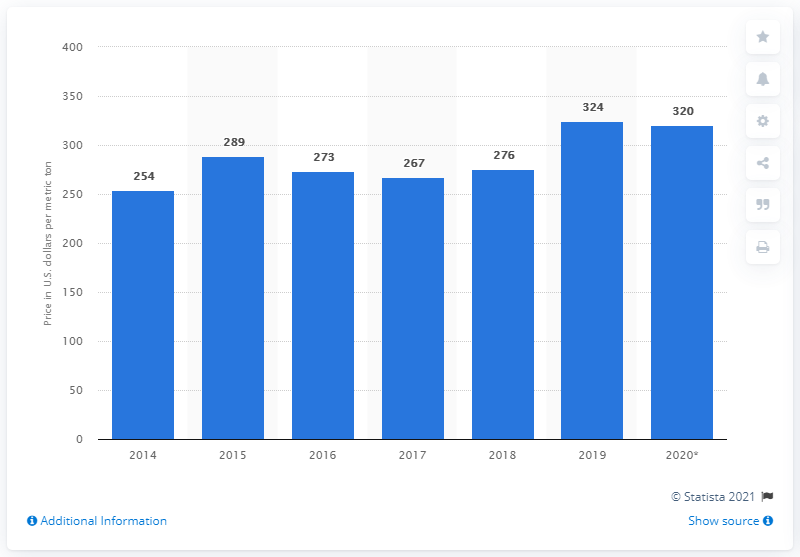Identify some key points in this picture. The average price of fluorspar in the United States in dollars per metric ton in 2020 was 320. 